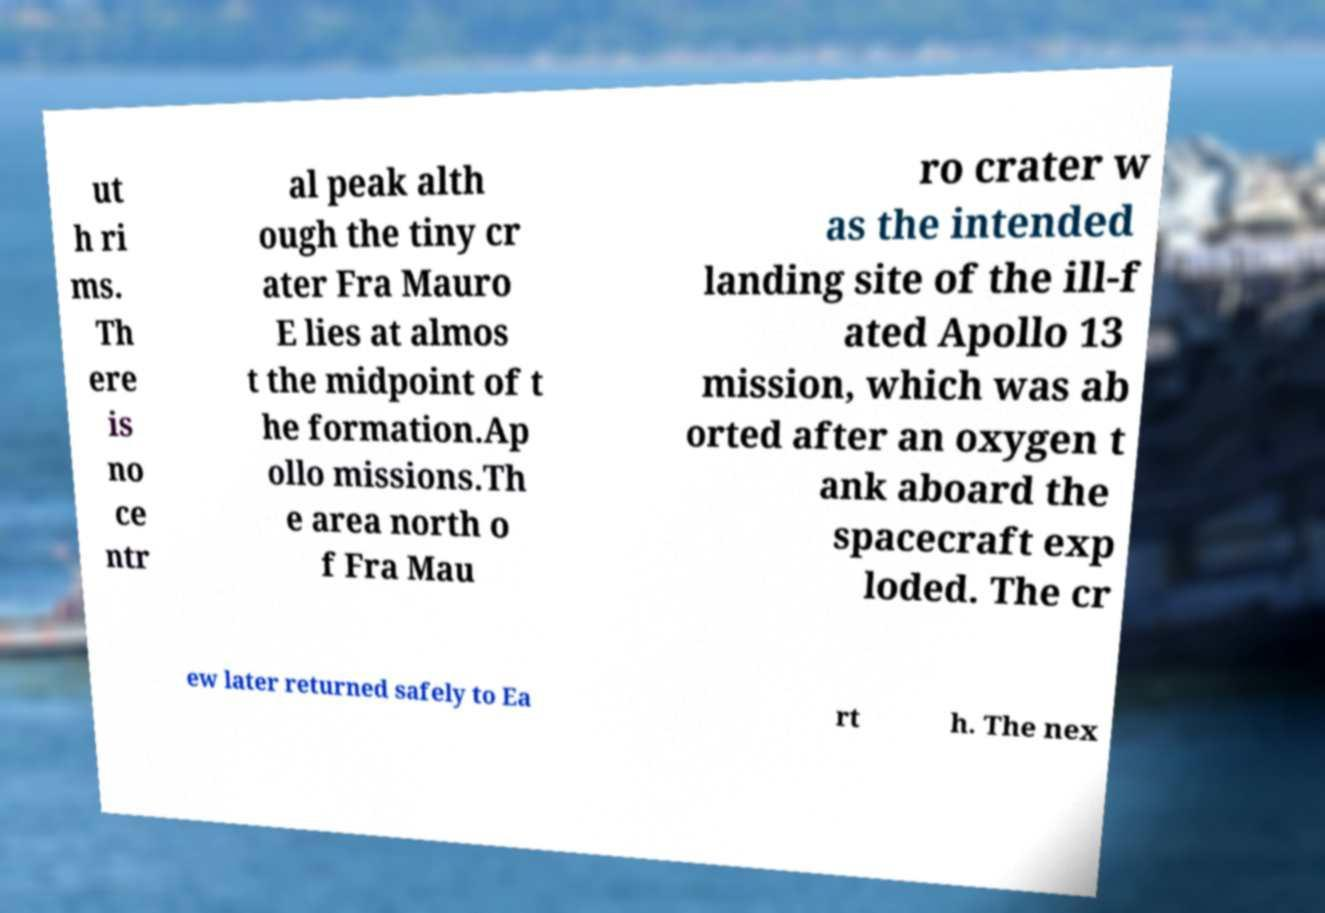I need the written content from this picture converted into text. Can you do that? ut h ri ms. Th ere is no ce ntr al peak alth ough the tiny cr ater Fra Mauro E lies at almos t the midpoint of t he formation.Ap ollo missions.Th e area north o f Fra Mau ro crater w as the intended landing site of the ill-f ated Apollo 13 mission, which was ab orted after an oxygen t ank aboard the spacecraft exp loded. The cr ew later returned safely to Ea rt h. The nex 